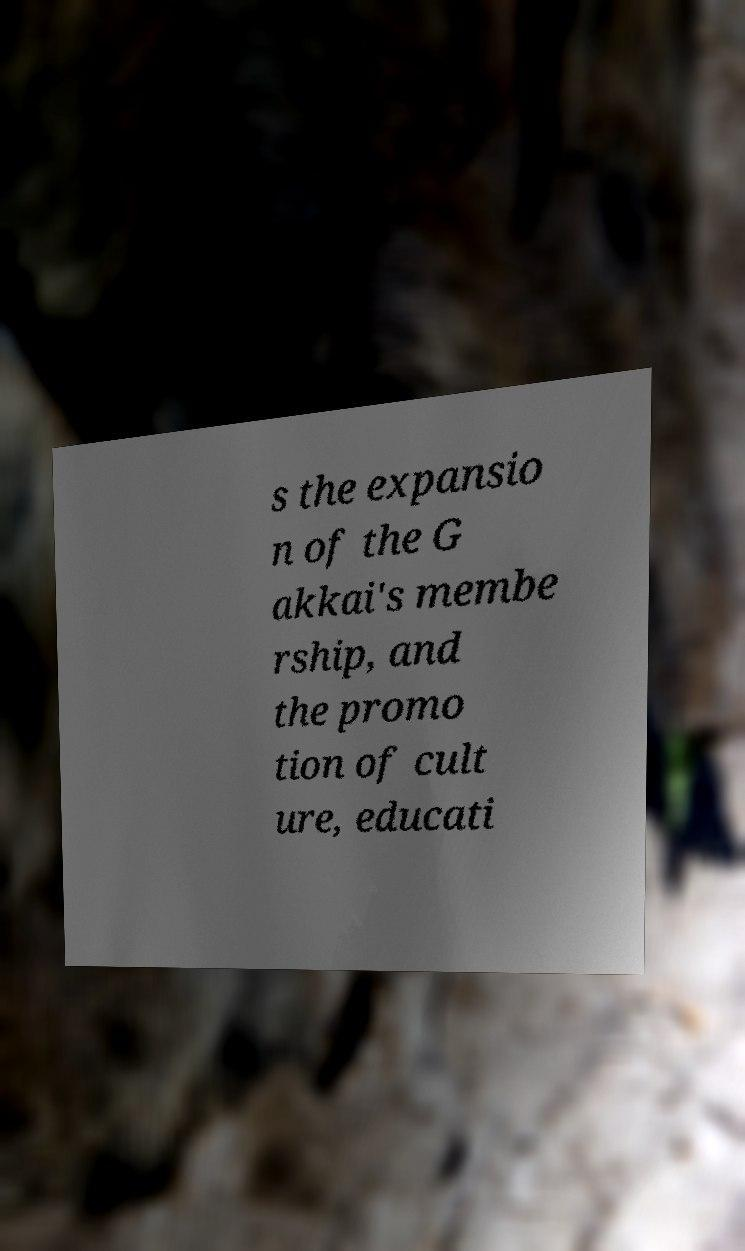Can you accurately transcribe the text from the provided image for me? s the expansio n of the G akkai's membe rship, and the promo tion of cult ure, educati 